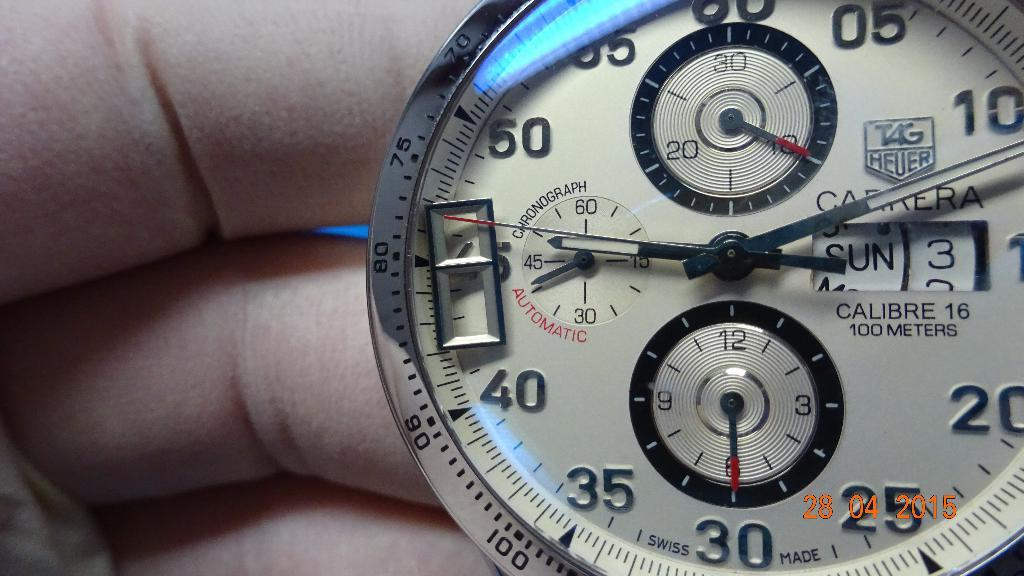<image>
Offer a succinct explanation of the picture presented. Person holding a watch that says the date is Sunday 3rd. 